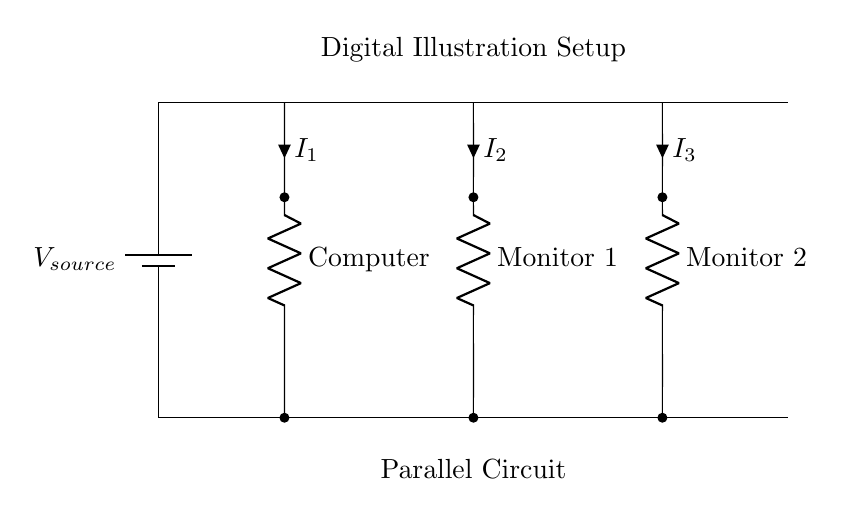What is the power source in this circuit? The power source is indicated as a battery, labeled V_source, which provides the necessary voltage for the circuit.
Answer: battery How many monitors are connected in this circuit? The circuit diagram shows two monitors labeled as Monitor 1 and Monitor 2, indicating there are two connected monitors.
Answer: two What type of circuit is shown here? The circuit is labeled as a parallel circuit, which means that the components are connected alongside each other, allowing for independent operation.
Answer: parallel What is the current flowing through the computer? The current through the computer is labeled as I_1; the diagram indicates that this is the current dedicated to the computer component.
Answer: I_1 How does the voltage across each component compare? In a parallel circuit, the voltage across each component is the same and equal to the source voltage, as indicated by the layout.
Answer: V_source What happens to the other components if one monitor fails? If one monitor fails in a parallel circuit, the other components continue to operate normally since they are independently connected to the power source.
Answer: continue to operate What is the significance of the short lines connected to each component? The short lines represent connections (or leads) to each component, highlighting how power from the source reaches each one without affecting the operation of the others.
Answer: connections 